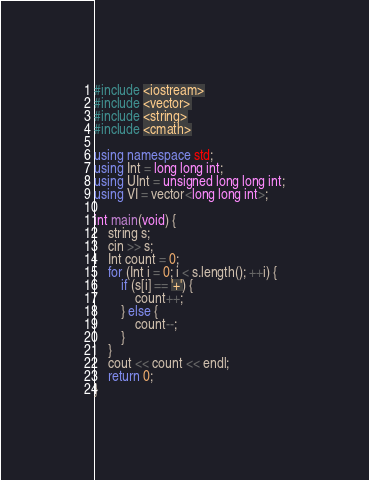<code> <loc_0><loc_0><loc_500><loc_500><_C++_>#include <iostream>
#include <vector>
#include <string>
#include <cmath>
 
using namespace std;
using Int = long long int;
using UInt = unsigned long long int;
using VI = vector<long long int>;

int main(void) {
    string s;
    cin >> s;
    Int count = 0;
    for (Int i = 0; i < s.length(); ++i) {
        if (s[i] == '+') {
            count++;
        } else {
            count--;
        }
    }
    cout << count << endl;
    return 0;
}

</code> 